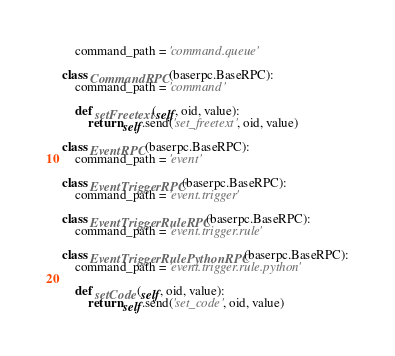Convert code to text. <code><loc_0><loc_0><loc_500><loc_500><_Python_>    command_path = 'command.queue'

class CommandRPC(baserpc.BaseRPC):
    command_path = 'command'

    def setFreetext(self, oid, value):
        return self.send('set_freetext', oid, value)

class EventRPC(baserpc.BaseRPC):
    command_path = 'event'

class EventTriggerRPC(baserpc.BaseRPC):
    command_path = 'event.trigger'

class EventTriggerRuleRPC(baserpc.BaseRPC):
    command_path = 'event.trigger.rule'

class EventTriggerRulePythonRPC(baserpc.BaseRPC):
    command_path = 'event.trigger.rule.python'

    def setCode(self, oid, value):
        return self.send('set_code', oid, value)

</code> 